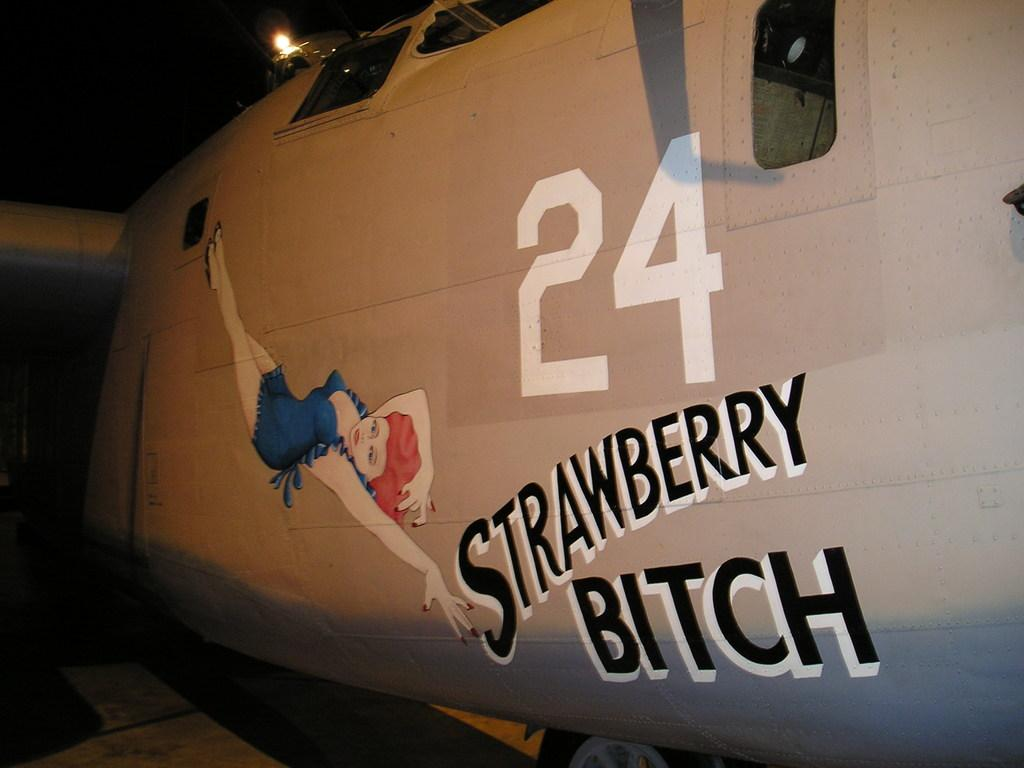<image>
Create a compact narrative representing the image presented. Plane number 24 has a painting of a redheaded lady and says, "Strawberry Bitch". 